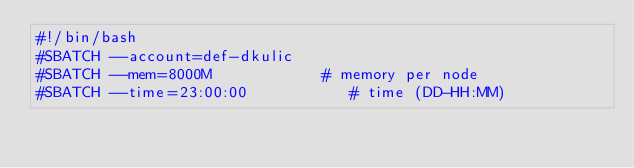Convert code to text. <code><loc_0><loc_0><loc_500><loc_500><_Bash_>#!/bin/bash
#SBATCH --account=def-dkulic
#SBATCH --mem=8000M            # memory per node
#SBATCH --time=23:00:00           # time (DD-HH:MM)</code> 